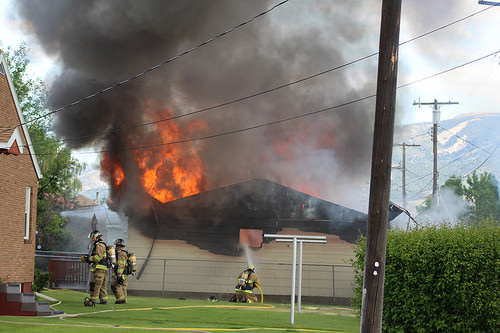<image>
Can you confirm if the fire is on the house? No. The fire is not positioned on the house. They may be near each other, but the fire is not supported by or resting on top of the house. Where is the fire in relation to the fireman? Is it on the fireman? No. The fire is not positioned on the fireman. They may be near each other, but the fire is not supported by or resting on top of the fireman. 